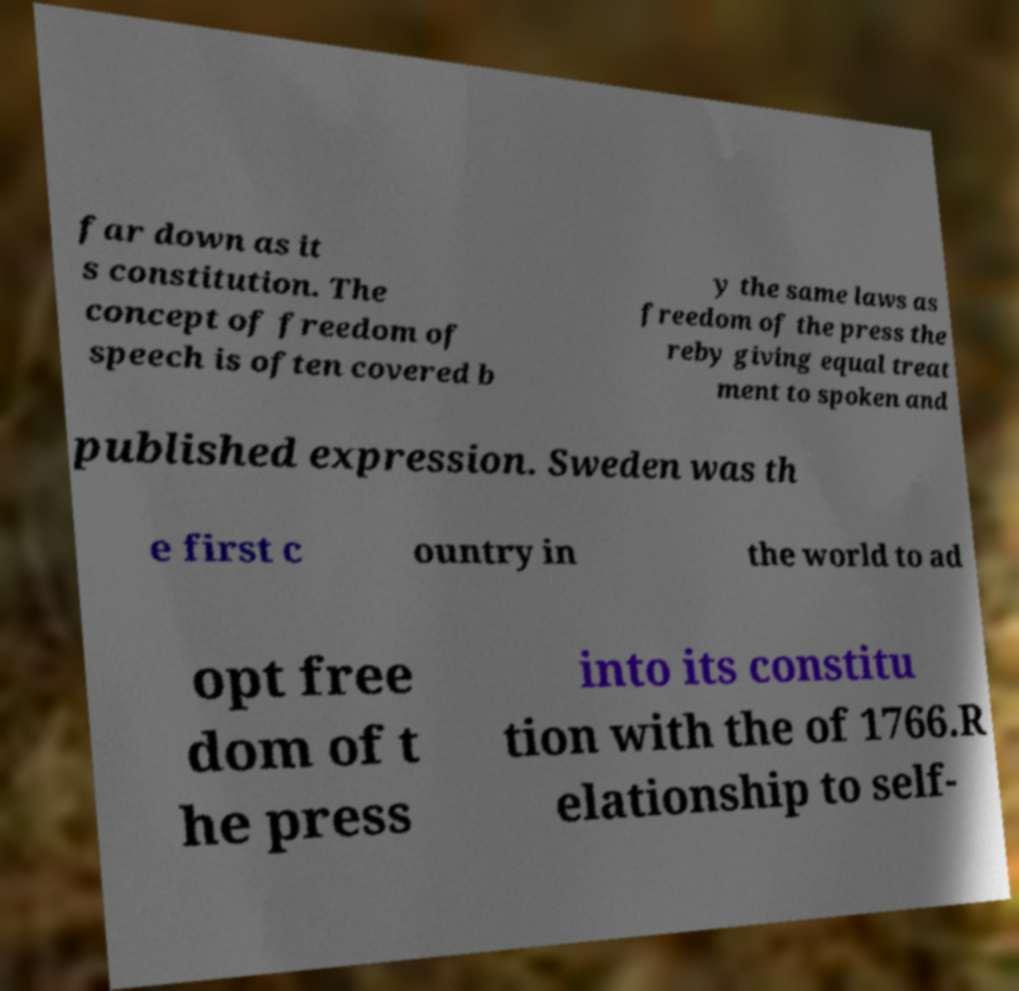Can you accurately transcribe the text from the provided image for me? far down as it s constitution. The concept of freedom of speech is often covered b y the same laws as freedom of the press the reby giving equal treat ment to spoken and published expression. Sweden was th e first c ountry in the world to ad opt free dom of t he press into its constitu tion with the of 1766.R elationship to self- 